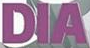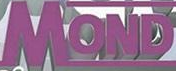What words are shown in these images in order, separated by a semicolon? DIA; MOND 